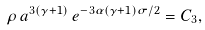Convert formula to latex. <formula><loc_0><loc_0><loc_500><loc_500>\rho \, a ^ { 3 ( \gamma + 1 ) } \, e ^ { - 3 \alpha ( \gamma + 1 ) \sigma / 2 } = C _ { 3 } ,</formula> 